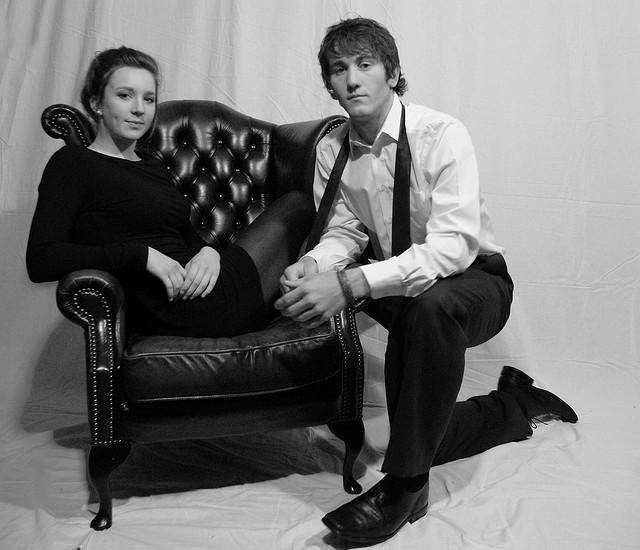How many shoes are in the picture?
Give a very brief answer. 2. How many people can be seen?
Give a very brief answer. 2. How many carrots are on the table?
Give a very brief answer. 0. 